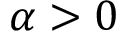<formula> <loc_0><loc_0><loc_500><loc_500>\alpha > 0</formula> 